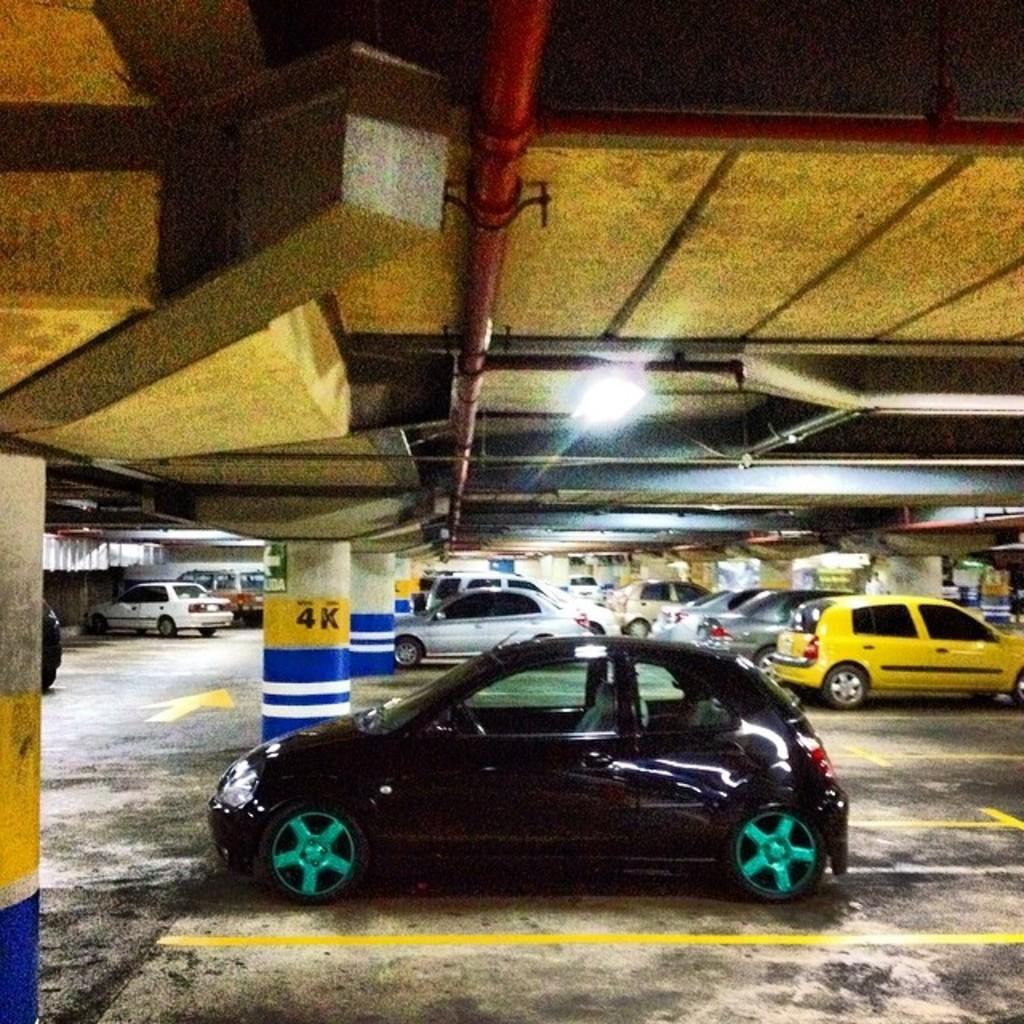Provide a one-sentence caption for the provided image. a car that is parked next to the 4K pole. 